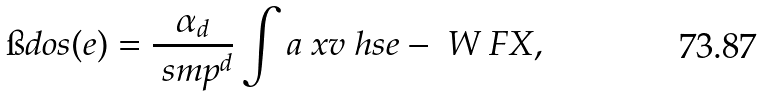Convert formula to latex. <formula><loc_0><loc_0><loc_500><loc_500>\i d o s ( e ) = \frac { \alpha _ { d } } { \ s m p ^ { d } } \int a \ x v \ h s { e - \ W \ F X } ,</formula> 